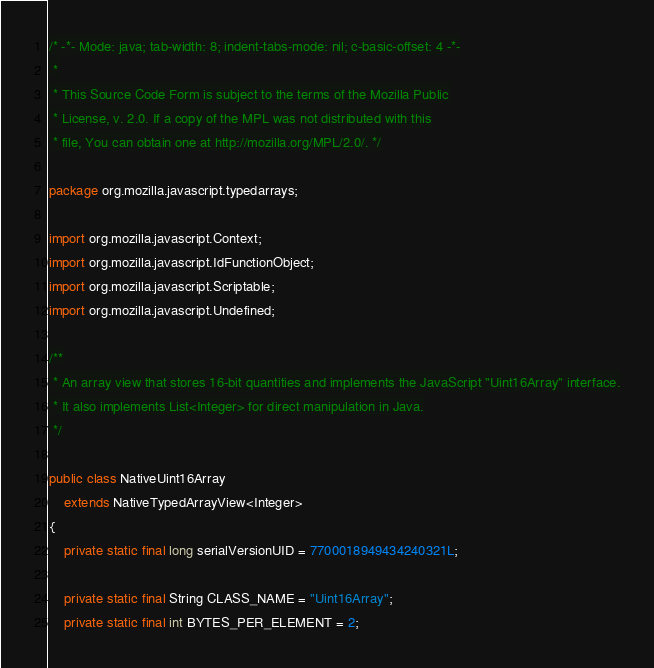Convert code to text. <code><loc_0><loc_0><loc_500><loc_500><_Java_>/* -*- Mode: java; tab-width: 8; indent-tabs-mode: nil; c-basic-offset: 4 -*-
 *
 * This Source Code Form is subject to the terms of the Mozilla Public
 * License, v. 2.0. If a copy of the MPL was not distributed with this
 * file, You can obtain one at http://mozilla.org/MPL/2.0/. */

package org.mozilla.javascript.typedarrays;

import org.mozilla.javascript.Context;
import org.mozilla.javascript.IdFunctionObject;
import org.mozilla.javascript.Scriptable;
import org.mozilla.javascript.Undefined;

/**
 * An array view that stores 16-bit quantities and implements the JavaScript "Uint16Array" interface.
 * It also implements List<Integer> for direct manipulation in Java.
 */

public class NativeUint16Array
    extends NativeTypedArrayView<Integer>
{
    private static final long serialVersionUID = 7700018949434240321L;

    private static final String CLASS_NAME = "Uint16Array";
    private static final int BYTES_PER_ELEMENT = 2;
</code> 